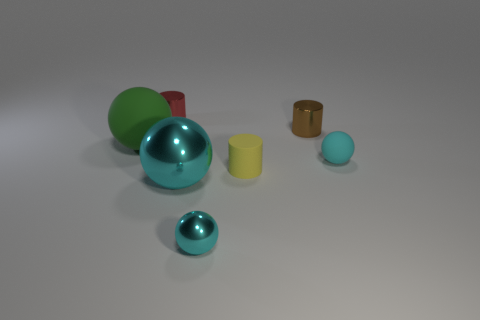What number of shiny objects are behind the small cyan sphere in front of the cyan matte thing?
Provide a succinct answer. 3. What number of cubes are small brown shiny objects or yellow objects?
Keep it short and to the point. 0. What color is the sphere that is both behind the big cyan ball and right of the large matte ball?
Keep it short and to the point. Cyan. Is there anything else that has the same color as the large matte thing?
Offer a very short reply. No. There is a small rubber object that is in front of the cyan thing behind the large cyan metallic object; what color is it?
Offer a terse response. Yellow. Is the size of the yellow cylinder the same as the brown metal cylinder?
Offer a very short reply. Yes. Are the big object that is in front of the green object and the small cylinder right of the tiny yellow matte cylinder made of the same material?
Your response must be concise. Yes. There is a big rubber thing behind the small cyan sphere that is to the left of the rubber ball that is to the right of the green ball; what is its shape?
Your answer should be compact. Sphere. Are there more tiny green things than small brown shiny objects?
Provide a succinct answer. No. Is there a big metallic sphere?
Provide a short and direct response. Yes. 